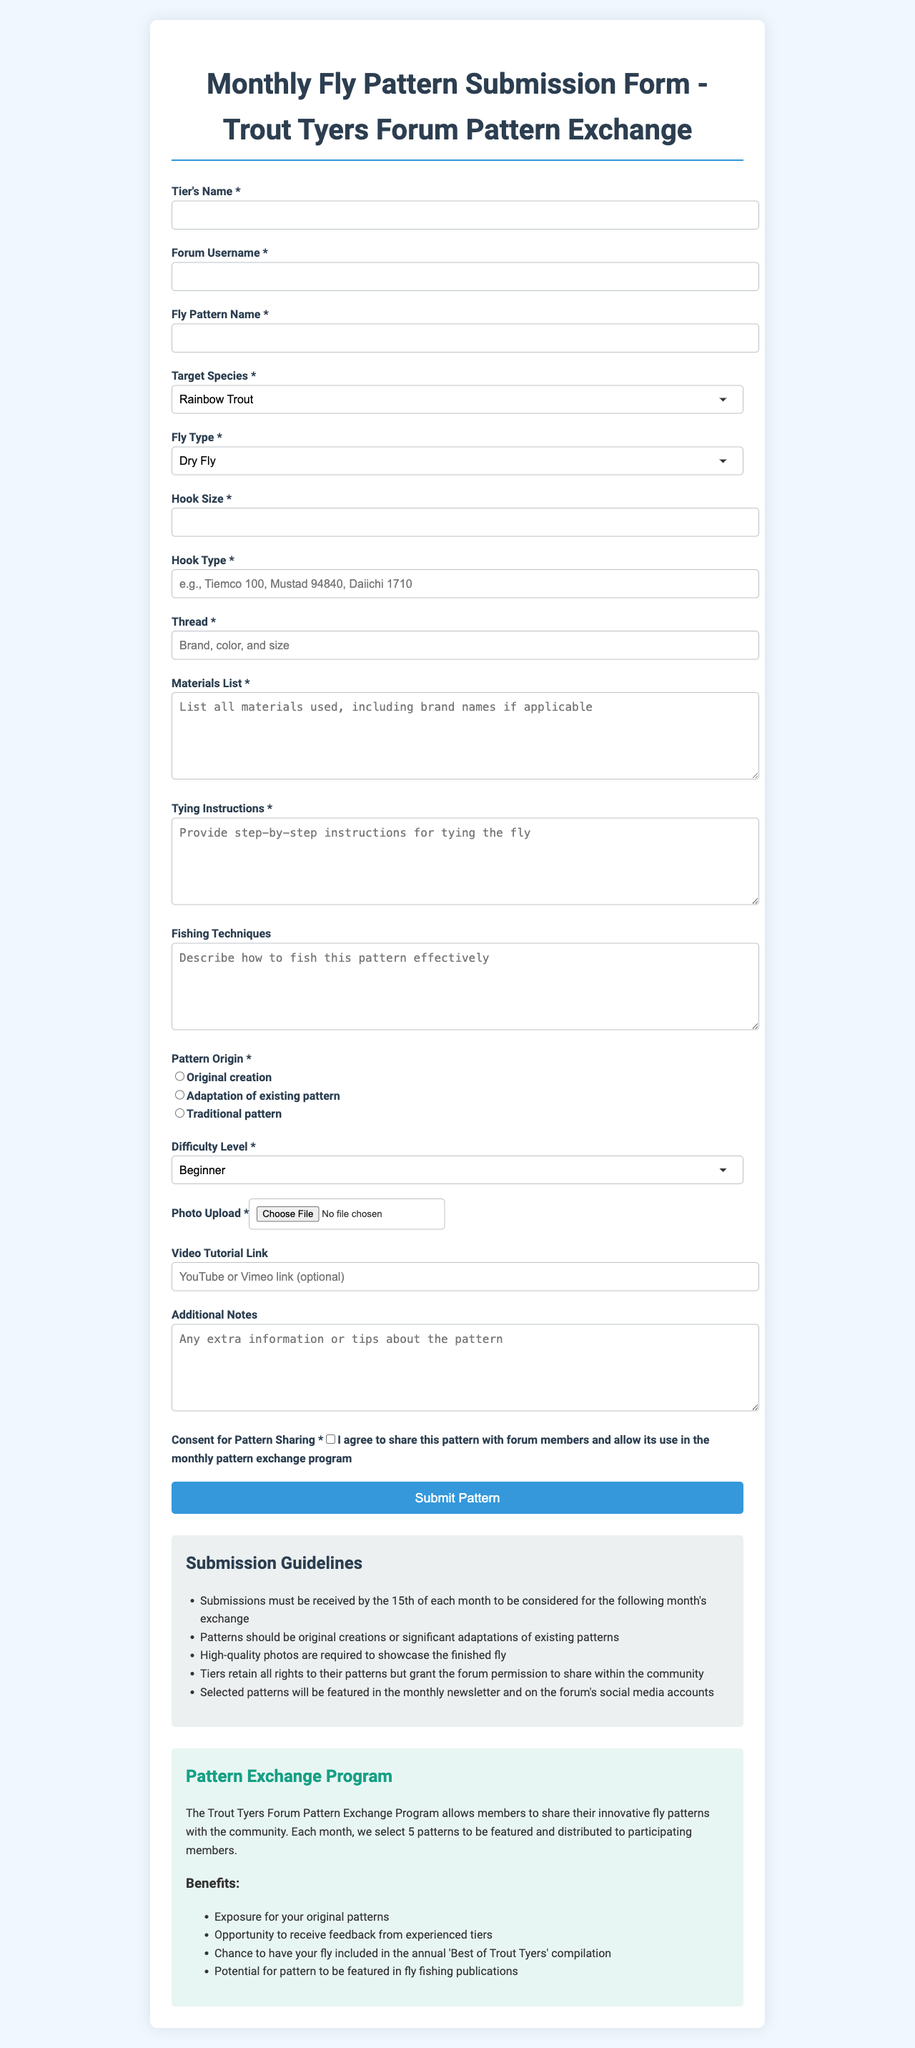what is the title of the form? The title of the form is provided at the top of the document and indicates the purpose of the submission.
Answer: Monthly Fly Pattern Submission Form - Trout Tyers Forum Pattern Exchange what is the maximum file size for photo upload? The maximum file size for uploading a photo is explicitly stated in the document.
Answer: 5MB what are the target species options in the dropdown? The target species options are listed in the dropdown section of the form, which allows users to select from various species.
Answer: Rainbow Trout, Brown Trout, Brook Trout, Cutthroat Trout, Steelhead, Salmon, Bass, Panfish, Other (please specify) how many patterns will be selected for the monthly newsletter? The document specifies how many patterns will be featured each month, which is relevant for participants interested in exposure.
Answer: 5 patterns is the video tutorial link mandatory? The document indicates whether the video tutorial link is required or optional for submissions.
Answer: Optional what are the required fields in the submission? The required fields are identified throughout the form, highlighting which information must be provided by participants.
Answer: Tier's Name, Forum Username, Fly Pattern Name, Target Species, Fly Type, Hook Size, Hook Type, Thread, Materials List, Tying Instructions, Pattern Origin, Difficulty Level, Photo Upload, Consent for Pattern Sharing which option indicates the origin of the pattern? The document contains a section where tier's must indicate the origin of their submitted pattern.
Answer: Original creation, Adaptation of existing pattern, Traditional pattern what is the submission deadline for the monthly pattern exchange? The document specifies the date by which all submissions must be received to be eligible for the following month's exchange.
Answer: 15th of each month what kind of rights do tiers retain over their patterns? The document addresses the rights that tiers maintain regarding their submitted patterns.
Answer: Tiers retain all rights to their patterns 